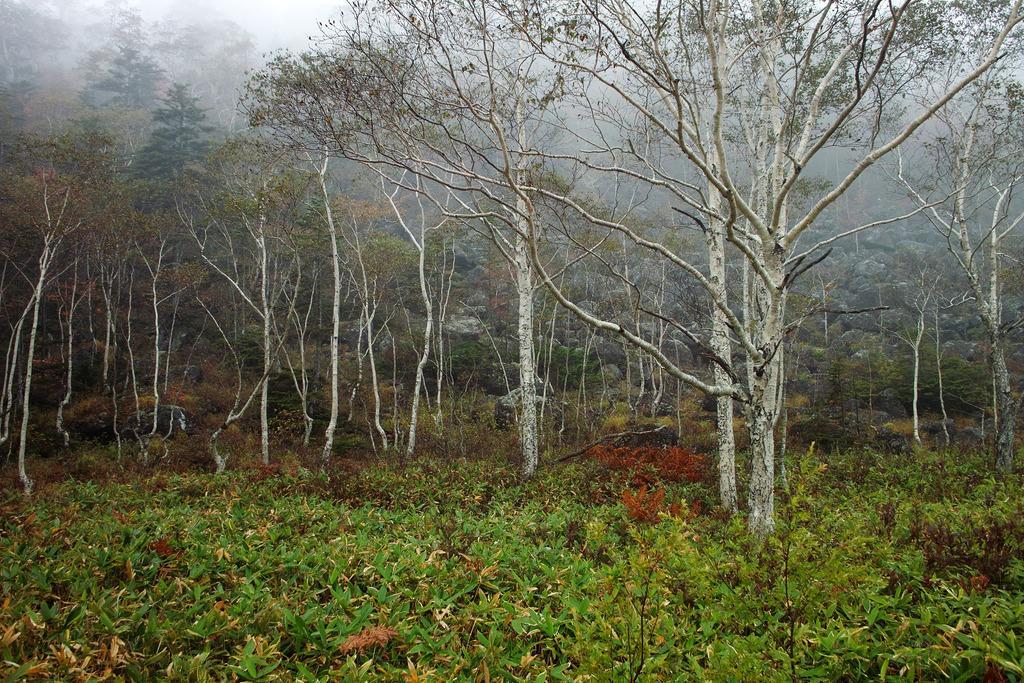Describe this image in one or two sentences. This image is taken outdoors. At the bottom of the image there are a few plants with green leaves and stems on the ground. In the middle of the image there are many trees with green leaves, stems and branches. At the top of the image there is the sky. 